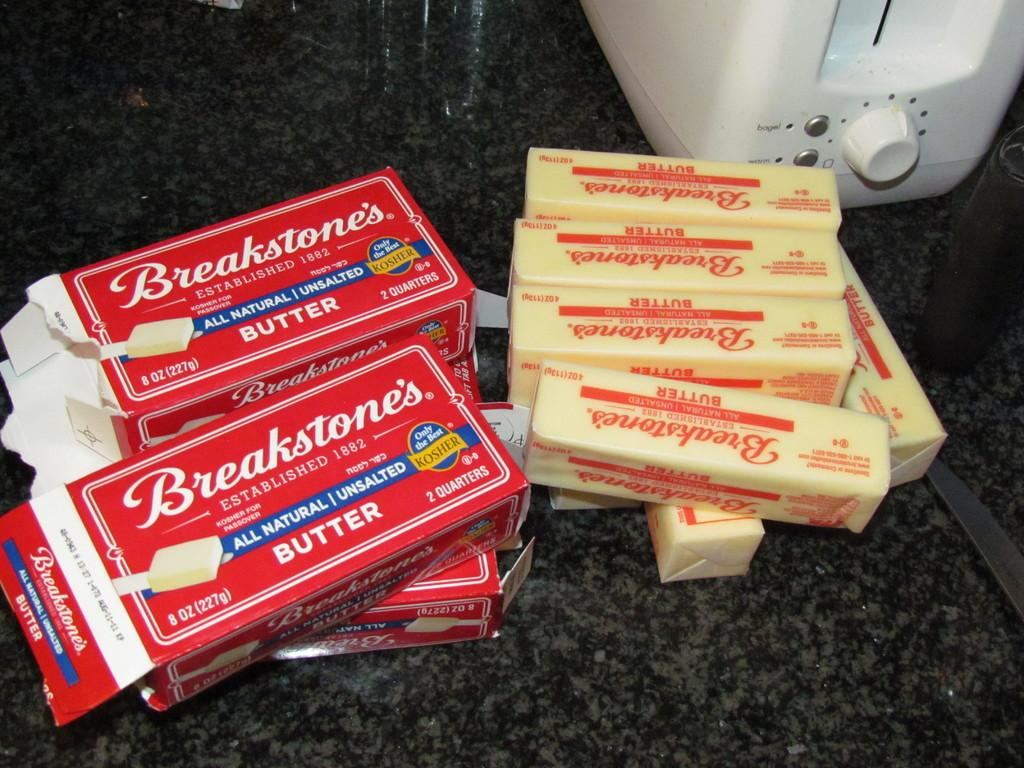<image>
Relay a brief, clear account of the picture shown. Several butter sticks made by the brand Breakstones's. 